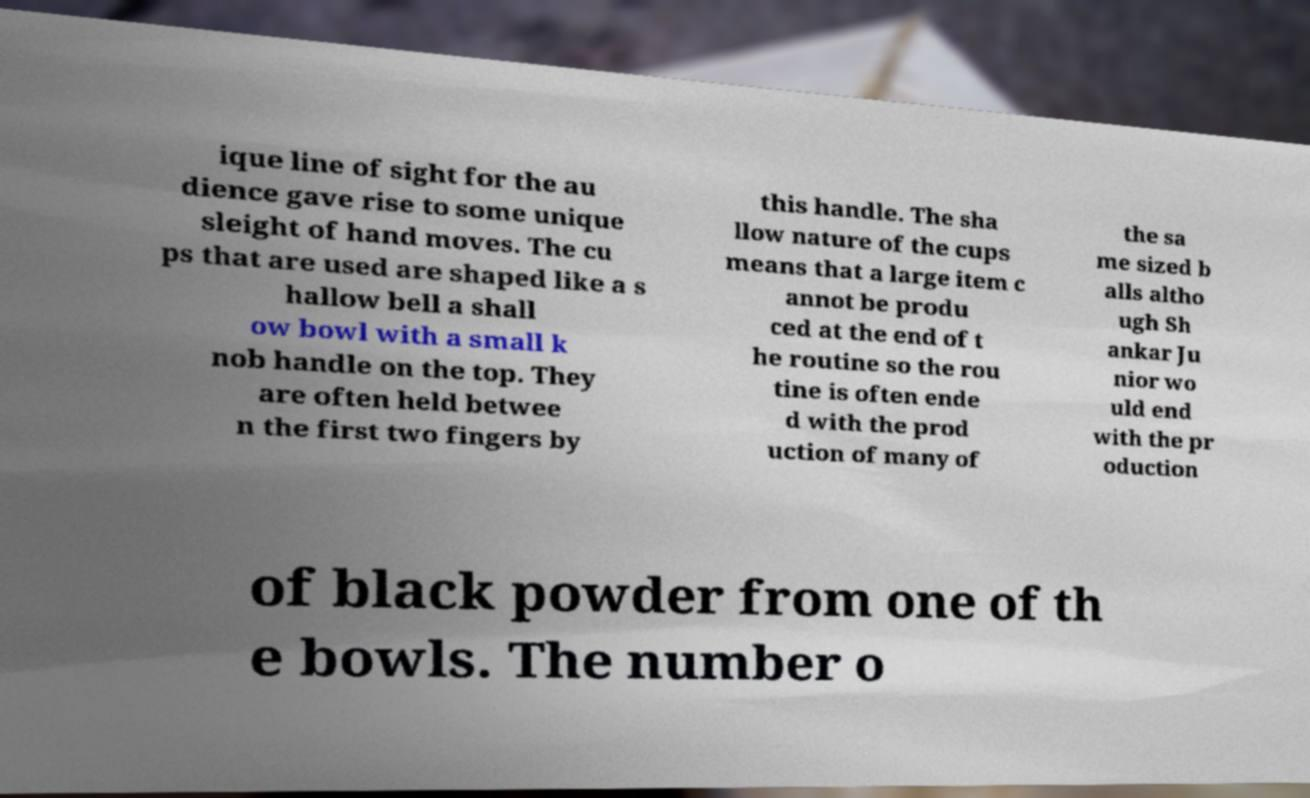Please read and relay the text visible in this image. What does it say? ique line of sight for the au dience gave rise to some unique sleight of hand moves. The cu ps that are used are shaped like a s hallow bell a shall ow bowl with a small k nob handle on the top. They are often held betwee n the first two fingers by this handle. The sha llow nature of the cups means that a large item c annot be produ ced at the end of t he routine so the rou tine is often ende d with the prod uction of many of the sa me sized b alls altho ugh Sh ankar Ju nior wo uld end with the pr oduction of black powder from one of th e bowls. The number o 